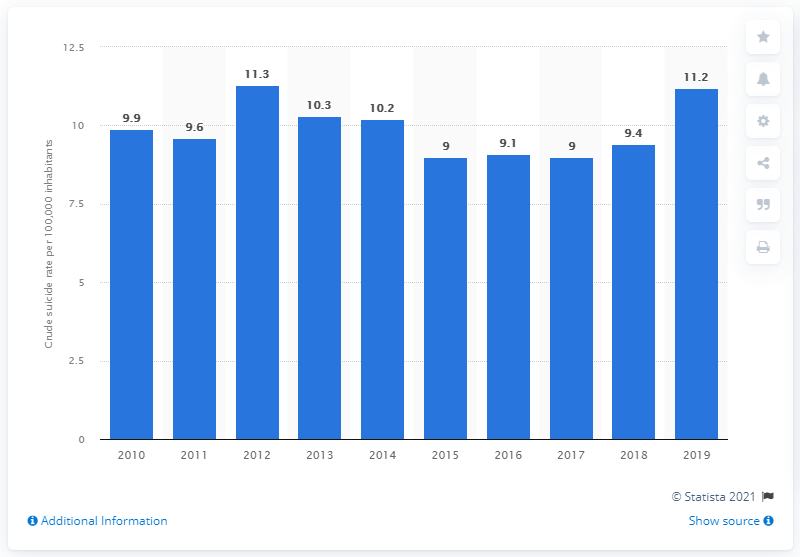List a handful of essential elements in this visual. According to data from 2019, the crude suicide rate in Singapore was 11.2 per 100,000 population. Singapore's crude suicide rate was at its highest in 2012. 